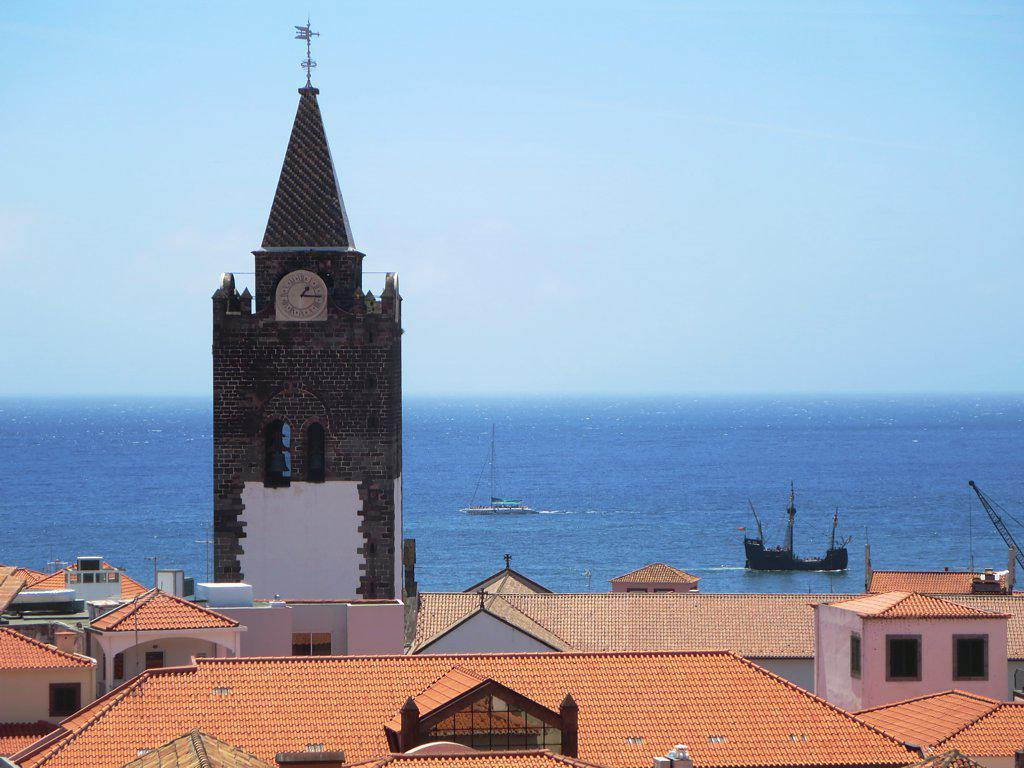What type of structures can be seen in the image? There are many building roofs in the image. Is there any specific feature on one of the buildings? Yes, there is a clock on a building in the image. What can be seen in the background of the image? Ships are visible on the water in the background of the image. What type of cabbage is being used to decorate the clock tower in the image? There is no cabbage present in the image, and the clock tower is not being decorated with any vegetables. 